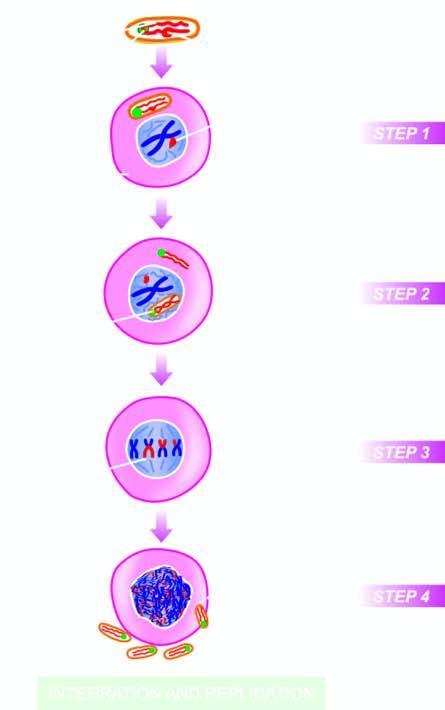does the viral envelope fuse with the plasma membrane of the host cell?
Answer the question using a single word or phrase. Yes 